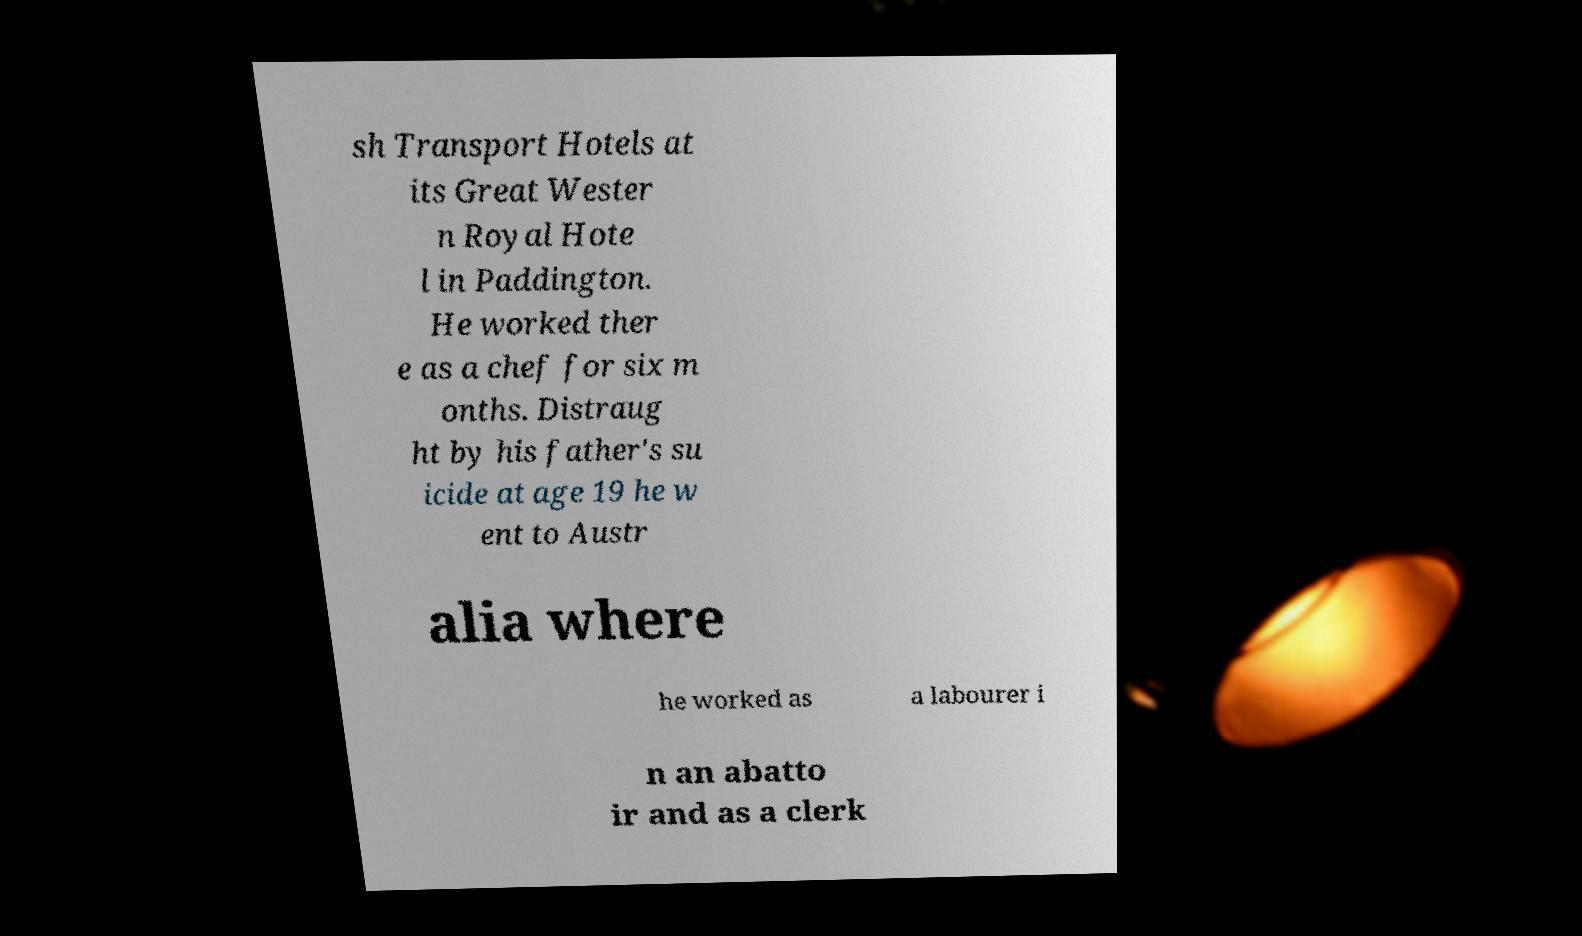What messages or text are displayed in this image? I need them in a readable, typed format. sh Transport Hotels at its Great Wester n Royal Hote l in Paddington. He worked ther e as a chef for six m onths. Distraug ht by his father's su icide at age 19 he w ent to Austr alia where he worked as a labourer i n an abatto ir and as a clerk 